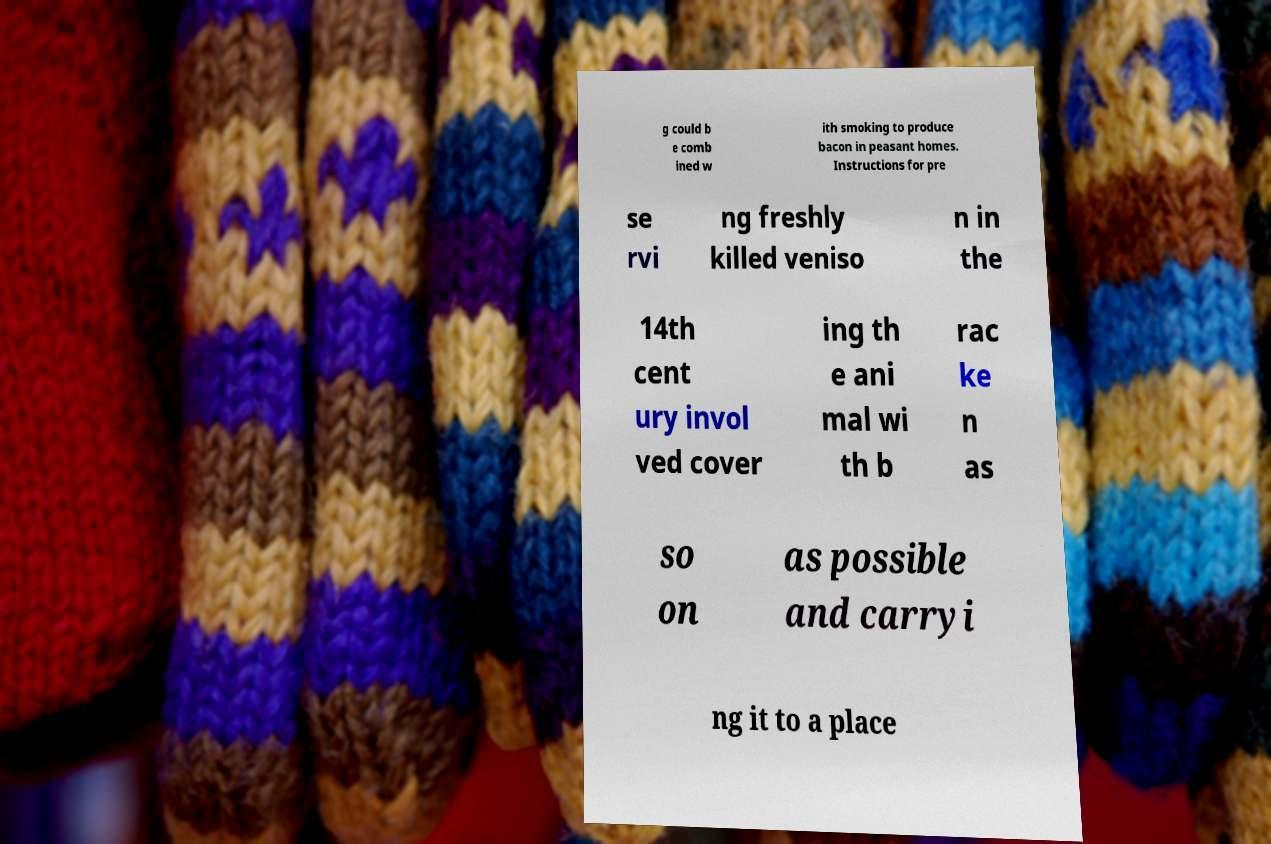For documentation purposes, I need the text within this image transcribed. Could you provide that? g could b e comb ined w ith smoking to produce bacon in peasant homes. Instructions for pre se rvi ng freshly killed veniso n in the 14th cent ury invol ved cover ing th e ani mal wi th b rac ke n as so on as possible and carryi ng it to a place 